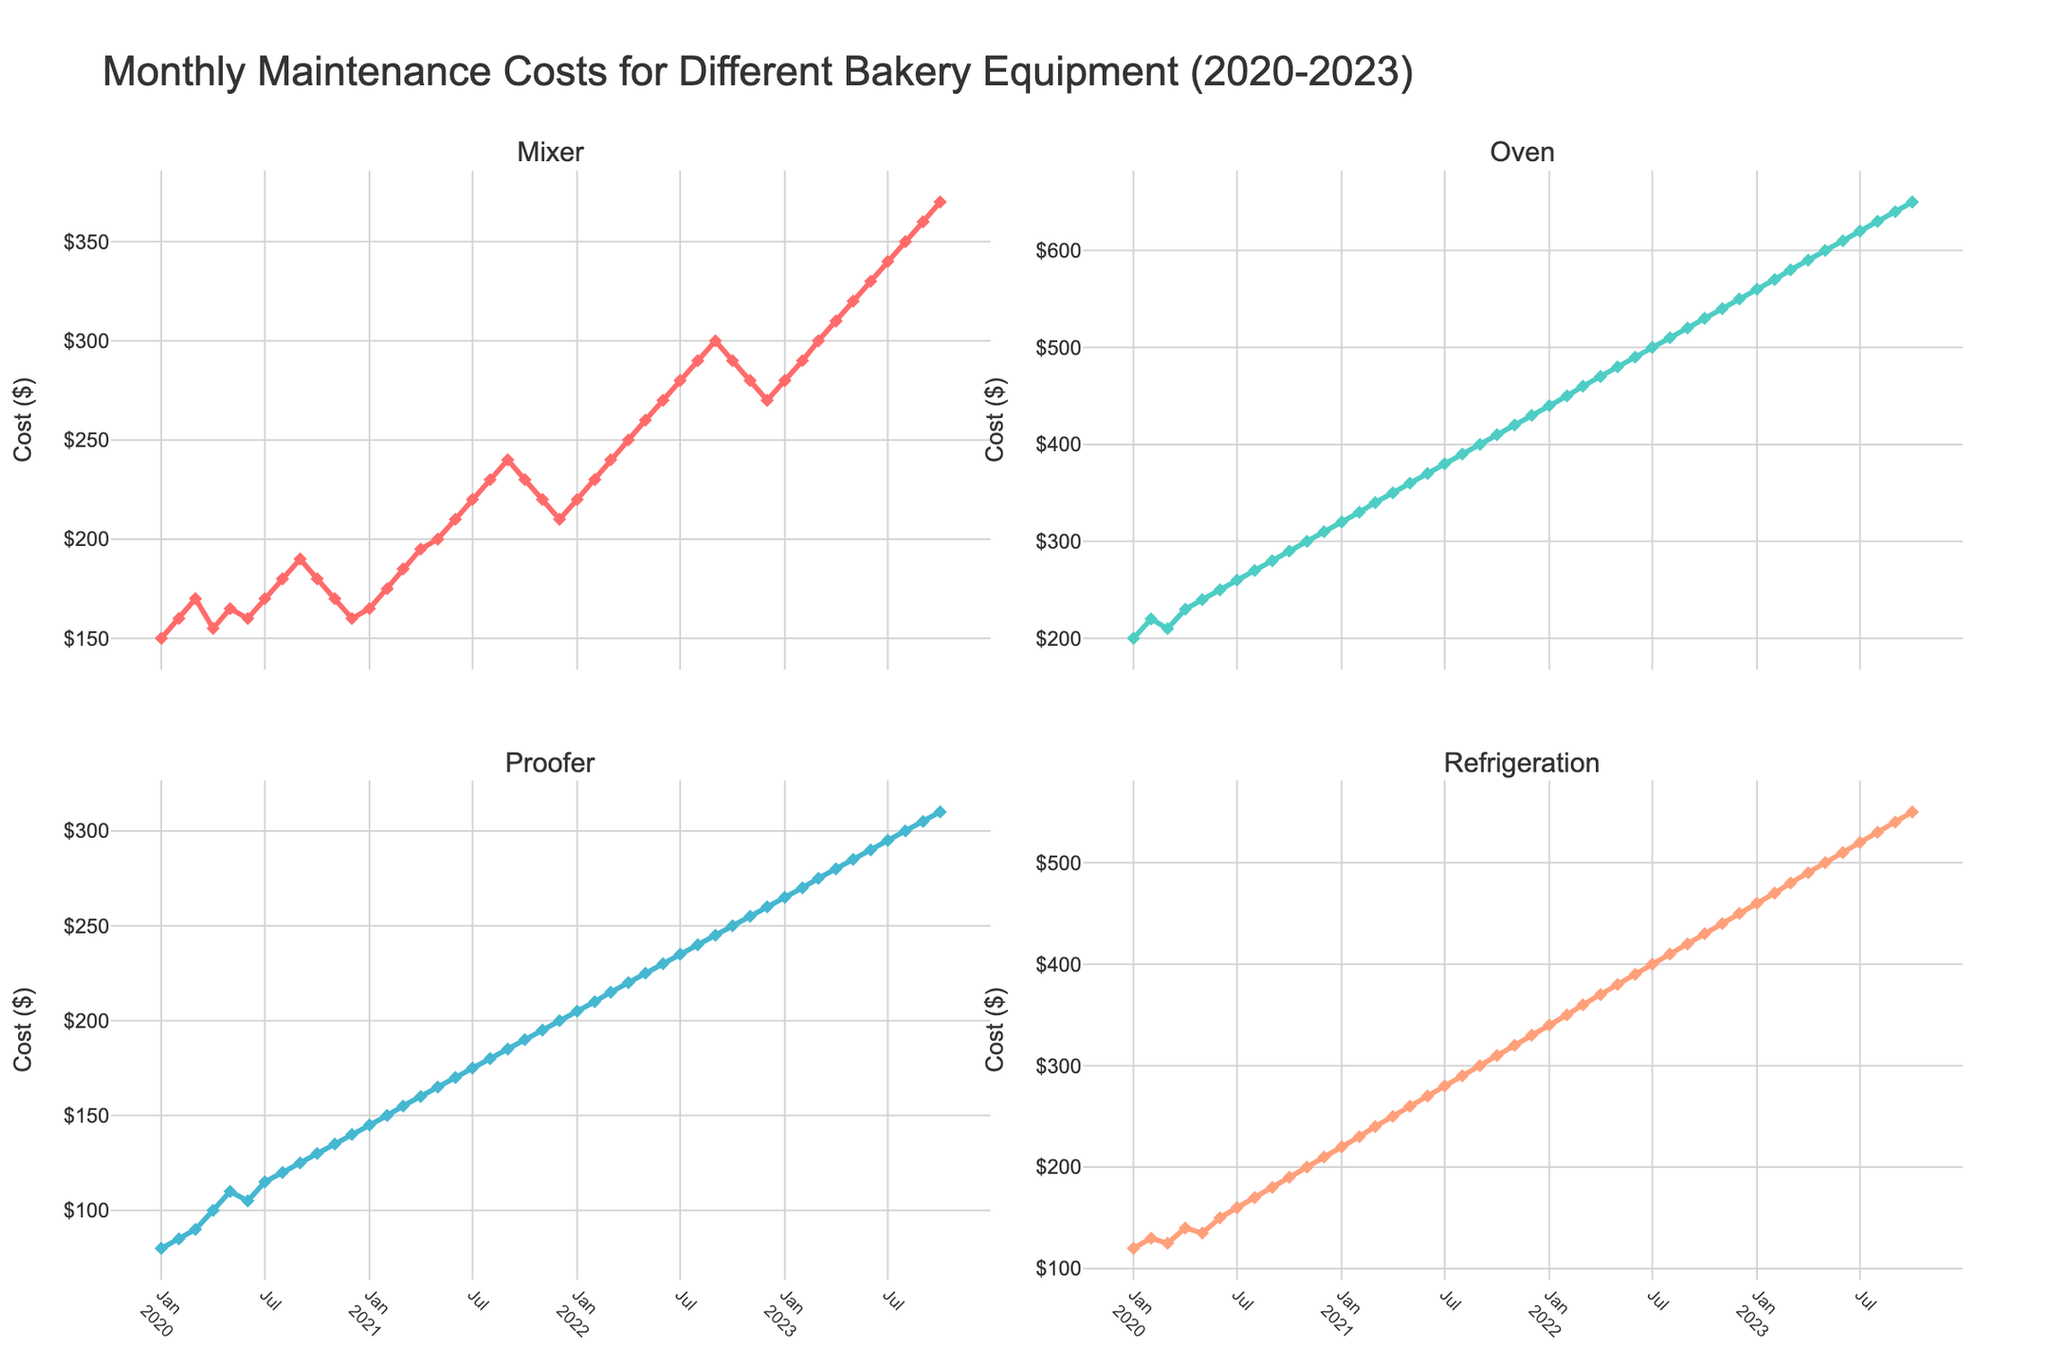What is the title of the figure? The title is usually located at the top of the figure and describes the main content of the plot.
Answer: Monthly Maintenance Costs for Different Bakery Equipment (2020-2023) What is the monthly maintenance cost for the oven in January 2022? To find the monthly maintenance cost for the oven in January 2022, look for the point on the Oven subplot that corresponds to January 2022.
Answer: $440 Which piece of bakery equipment had the highest maintenance cost in July 2023? Check each subplot for July 2023 and compare the maintenance costs.
Answer: Oven How has the maintenance cost for the Mixer changed from January 2020 to October 2023? Look at the trend line in the Mixer subplot from January 2020 to October 2023.
Answer: It increased from $150 to $370 What is the average monthly maintenance cost of the Proofer for the year 2021? Add up the monthly maintenance costs for the Proofer in 2021 and divide by 12 to find the average.
Answer: $160 Compare the maintenance cost trends of the Mixer and the Oven. Which one increased more rapidly over the three years? Analyze the slopes of the trend lines in the Mixer and Oven subplots to determine the rate of increase over time.
Answer: Oven In which month and year did Refrigeration have its highest maintenance cost, and what was the cost? Locate the peak point in the Refrigeration subplot and note the corresponding month and year as well as the cost value.
Answer: October 2023, $550 What are the costs of all the equipment in June 2020, and which one has the lowest cost? Check the costs for June 2020 in each subplot and compare to find the lowest.
Answer: Mixer ($160) By how much did the maintenance cost of the Mixer increase from January 2021 to January 2023? Subtract the cost in January 2021 from the cost in January 2023.
Answer: $115 Is there any equipment for which maintenance costs decreased between September 2022 and October 2023? If yes, which one? Examine the trends for each equipment between September 2022 and October 2023 to see if any lines show a decrease.
Answer: Yes, Oven 